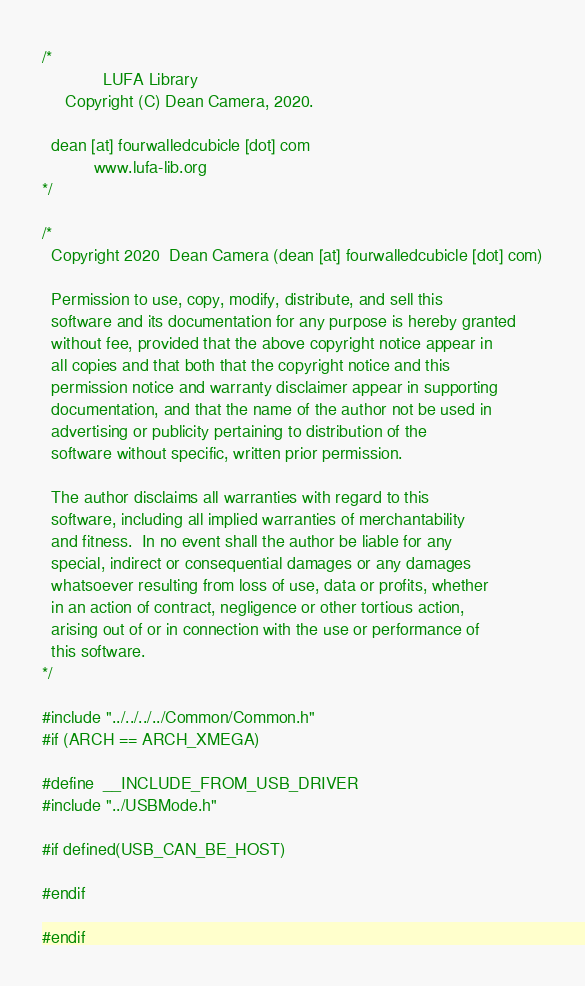Convert code to text. <code><loc_0><loc_0><loc_500><loc_500><_C_>/*
             LUFA Library
     Copyright (C) Dean Camera, 2020.

  dean [at] fourwalledcubicle [dot] com
           www.lufa-lib.org
*/

/*
  Copyright 2020  Dean Camera (dean [at] fourwalledcubicle [dot] com)

  Permission to use, copy, modify, distribute, and sell this
  software and its documentation for any purpose is hereby granted
  without fee, provided that the above copyright notice appear in
  all copies and that both that the copyright notice and this
  permission notice and warranty disclaimer appear in supporting
  documentation, and that the name of the author not be used in
  advertising or publicity pertaining to distribution of the
  software without specific, written prior permission.

  The author disclaims all warranties with regard to this
  software, including all implied warranties of merchantability
  and fitness.  In no event shall the author be liable for any
  special, indirect or consequential damages or any damages
  whatsoever resulting from loss of use, data or profits, whether
  in an action of contract, negligence or other tortious action,
  arising out of or in connection with the use or performance of
  this software.
*/

#include "../../../../Common/Common.h"
#if (ARCH == ARCH_XMEGA)

#define  __INCLUDE_FROM_USB_DRIVER
#include "../USBMode.h"

#if defined(USB_CAN_BE_HOST)

#endif

#endif
</code> 